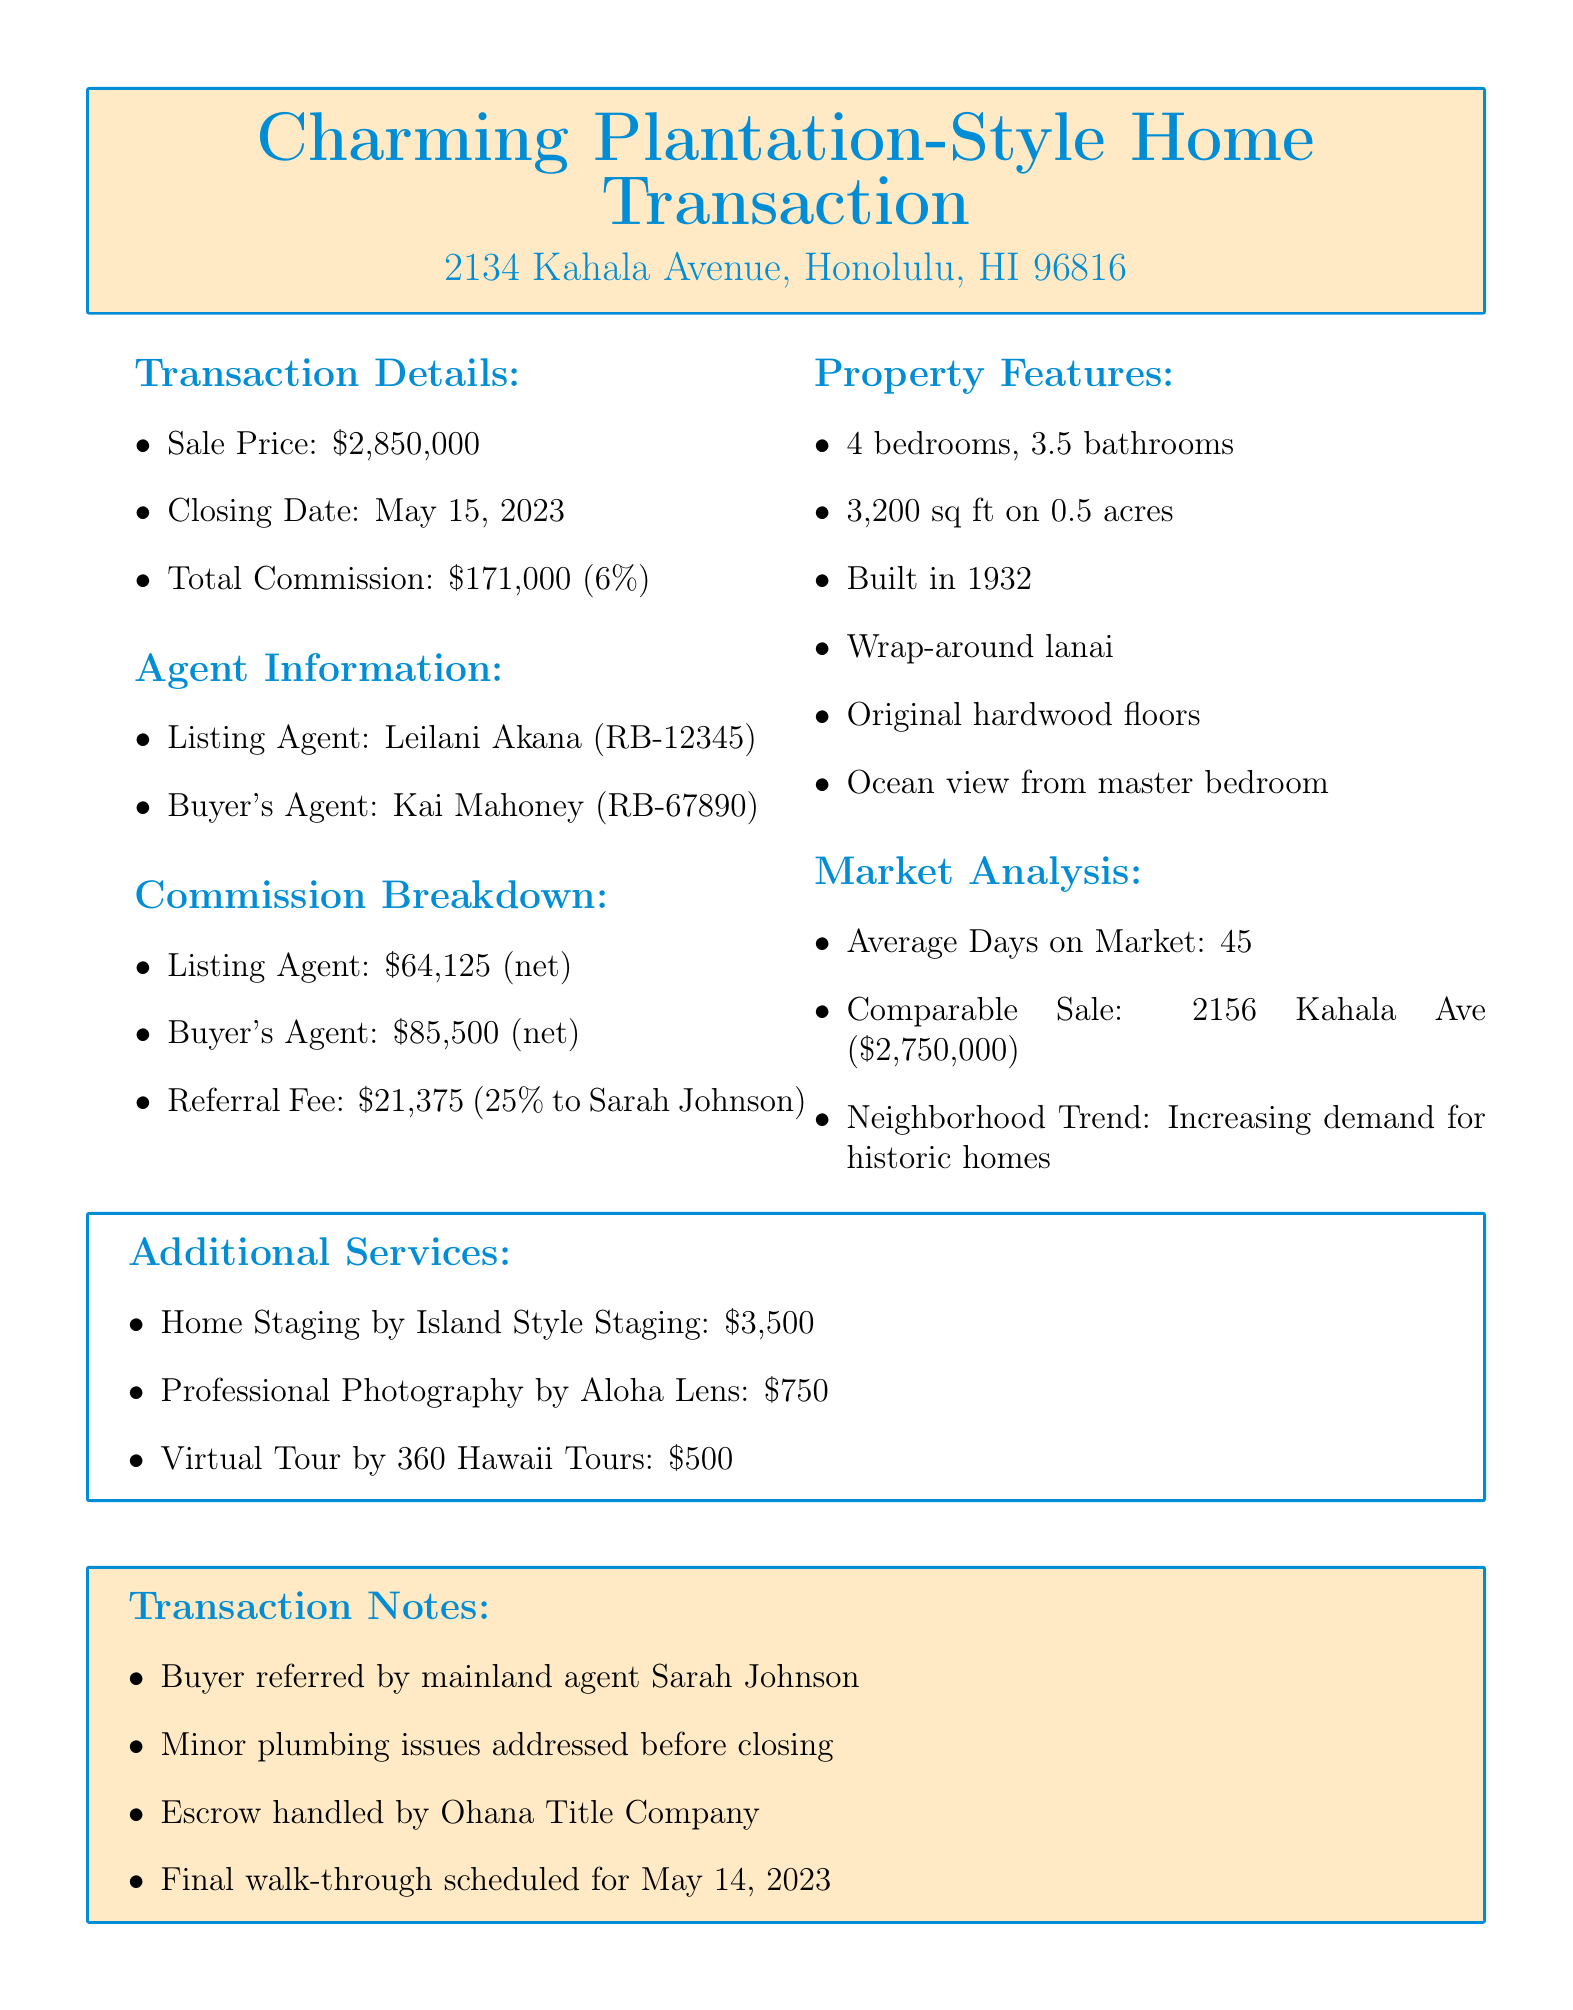What is the sale price of the home? The sale price is listed in the transaction details section of the document.
Answer: $2,850,000 Who is the listing agent? The listing agent's name is provided in the agent information section.
Answer: Leilani Akana What is the total commission amount? The total commission amount is specified in the commission breakdown section of the document.
Answer: $171,000 What percentage is the referral fee? The referral fee percentage is included in the referral fees section of the document.
Answer: 25% What is the listing agent's net earnings? The net earnings for the listing agent are detailed in the commission breakdown section.
Answer: $64,125 What notable feature provides an ocean view? This question requires knowledge from the property features section regarding specific characteristics of the home.
Answer: Master bedroom How many bedrooms does the home have? The number of bedrooms is listed under property features.
Answer: 4 Which brokerage represents the buyer's agent? The brokerage for the buyer's agent can be found in the agent information section of the document.
Answer: Paradise Properties Hawaii What type of home is being sold? The property type is outlined in the transaction details section.
Answer: Plantation-style home 